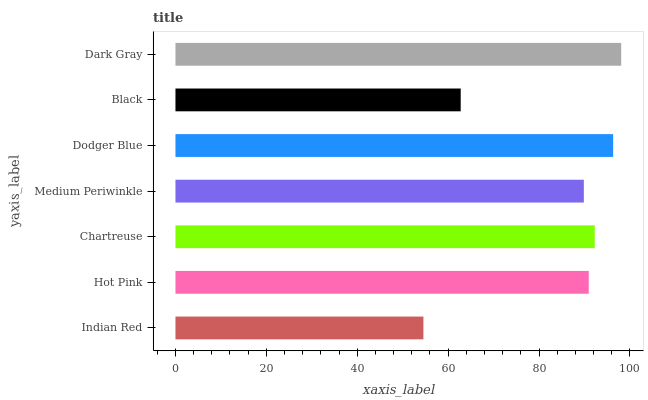Is Indian Red the minimum?
Answer yes or no. Yes. Is Dark Gray the maximum?
Answer yes or no. Yes. Is Hot Pink the minimum?
Answer yes or no. No. Is Hot Pink the maximum?
Answer yes or no. No. Is Hot Pink greater than Indian Red?
Answer yes or no. Yes. Is Indian Red less than Hot Pink?
Answer yes or no. Yes. Is Indian Red greater than Hot Pink?
Answer yes or no. No. Is Hot Pink less than Indian Red?
Answer yes or no. No. Is Hot Pink the high median?
Answer yes or no. Yes. Is Hot Pink the low median?
Answer yes or no. Yes. Is Dodger Blue the high median?
Answer yes or no. No. Is Black the low median?
Answer yes or no. No. 